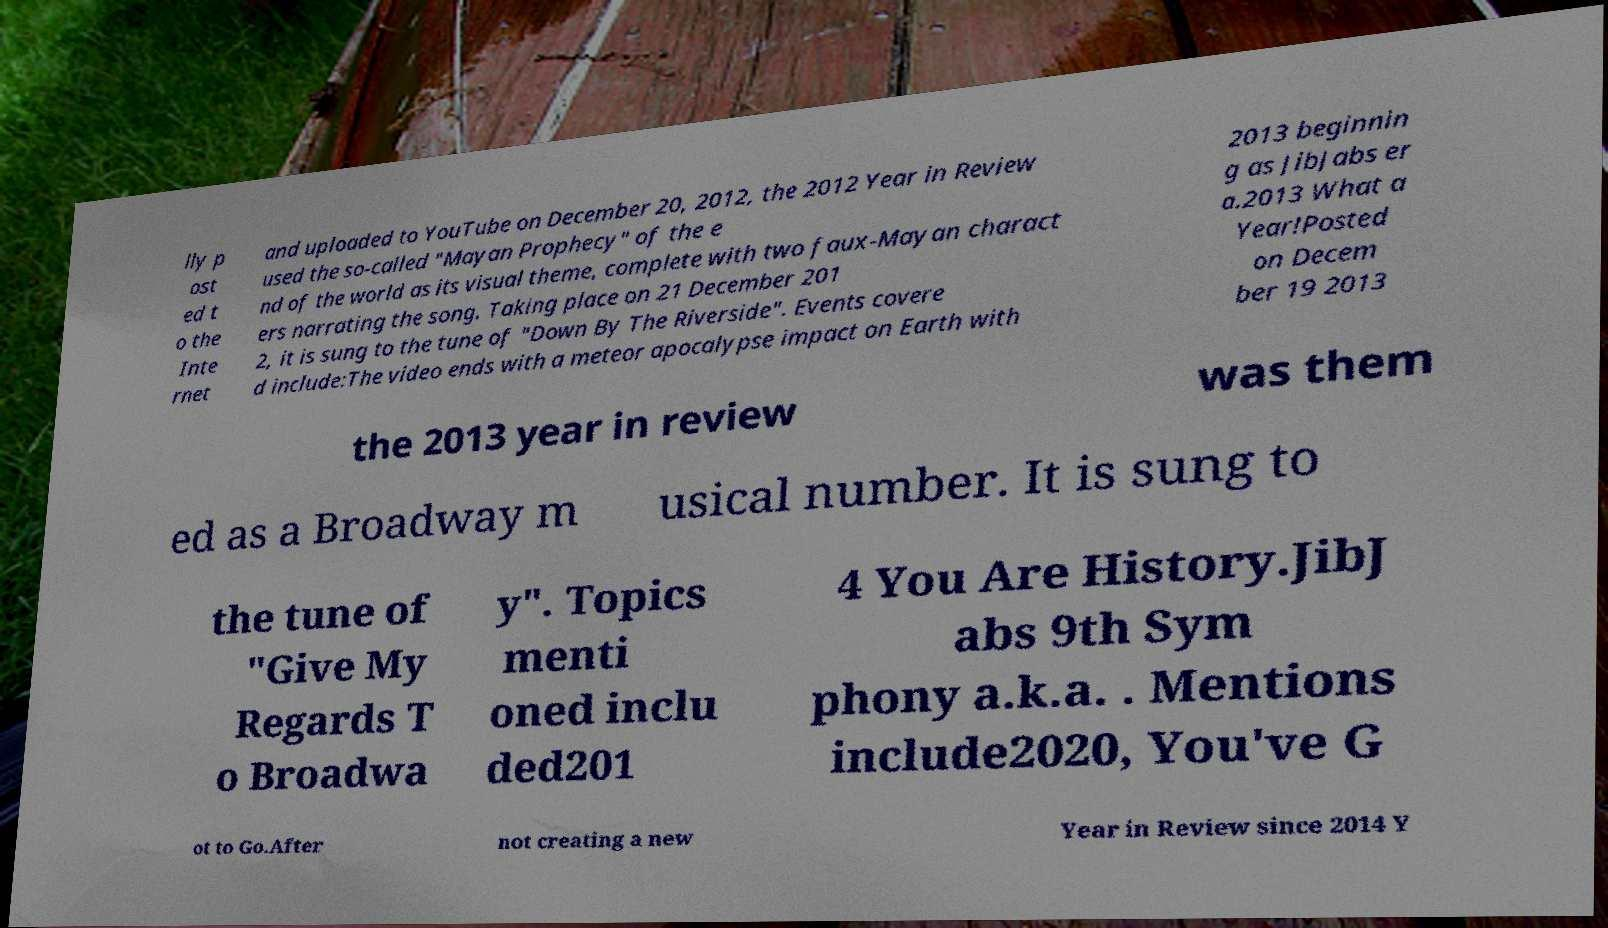What messages or text are displayed in this image? I need them in a readable, typed format. lly p ost ed t o the Inte rnet and uploaded to YouTube on December 20, 2012, the 2012 Year in Review used the so-called "Mayan Prophecy" of the e nd of the world as its visual theme, complete with two faux-Mayan charact ers narrating the song. Taking place on 21 December 201 2, it is sung to the tune of "Down By The Riverside". Events covere d include:The video ends with a meteor apocalypse impact on Earth with 2013 beginnin g as JibJabs er a.2013 What a Year!Posted on Decem ber 19 2013 the 2013 year in review was them ed as a Broadway m usical number. It is sung to the tune of "Give My Regards T o Broadwa y". Topics menti oned inclu ded201 4 You Are History.JibJ abs 9th Sym phony a.k.a. . Mentions include2020, You've G ot to Go.After not creating a new Year in Review since 2014 Y 